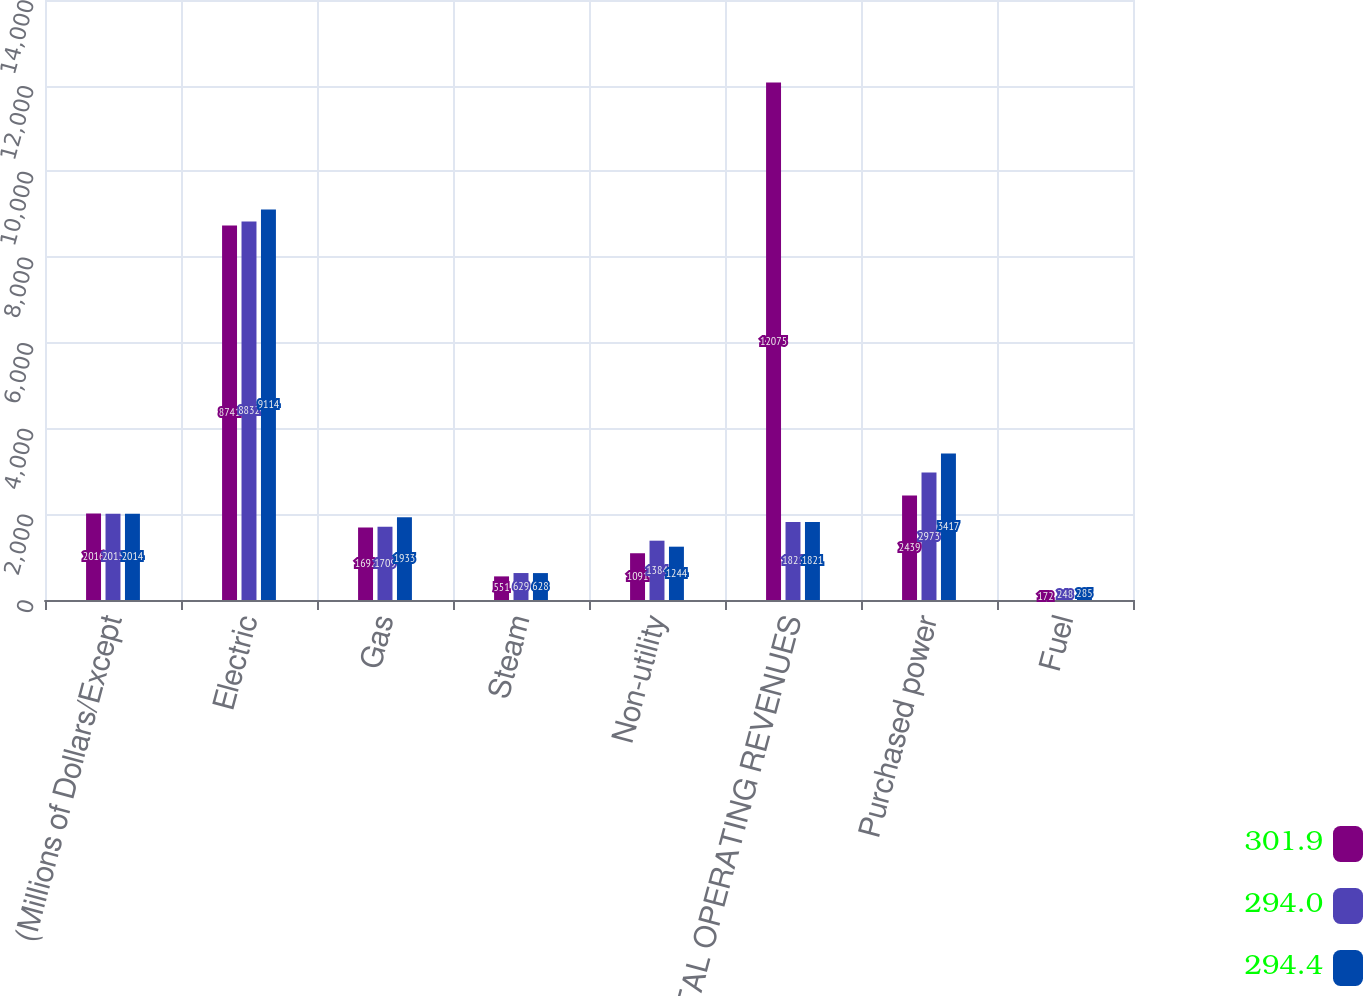Convert chart. <chart><loc_0><loc_0><loc_500><loc_500><stacked_bar_chart><ecel><fcel>(Millions of Dollars/Except<fcel>Electric<fcel>Gas<fcel>Steam<fcel>Non-utility<fcel>TOTAL OPERATING REVENUES<fcel>Purchased power<fcel>Fuel<nl><fcel>301.9<fcel>2016<fcel>8741<fcel>1692<fcel>551<fcel>1091<fcel>12075<fcel>2439<fcel>172<nl><fcel>294<fcel>2015<fcel>8832<fcel>1709<fcel>629<fcel>1384<fcel>1821<fcel>2973<fcel>248<nl><fcel>294.4<fcel>2014<fcel>9114<fcel>1933<fcel>628<fcel>1244<fcel>1821<fcel>3417<fcel>285<nl></chart> 